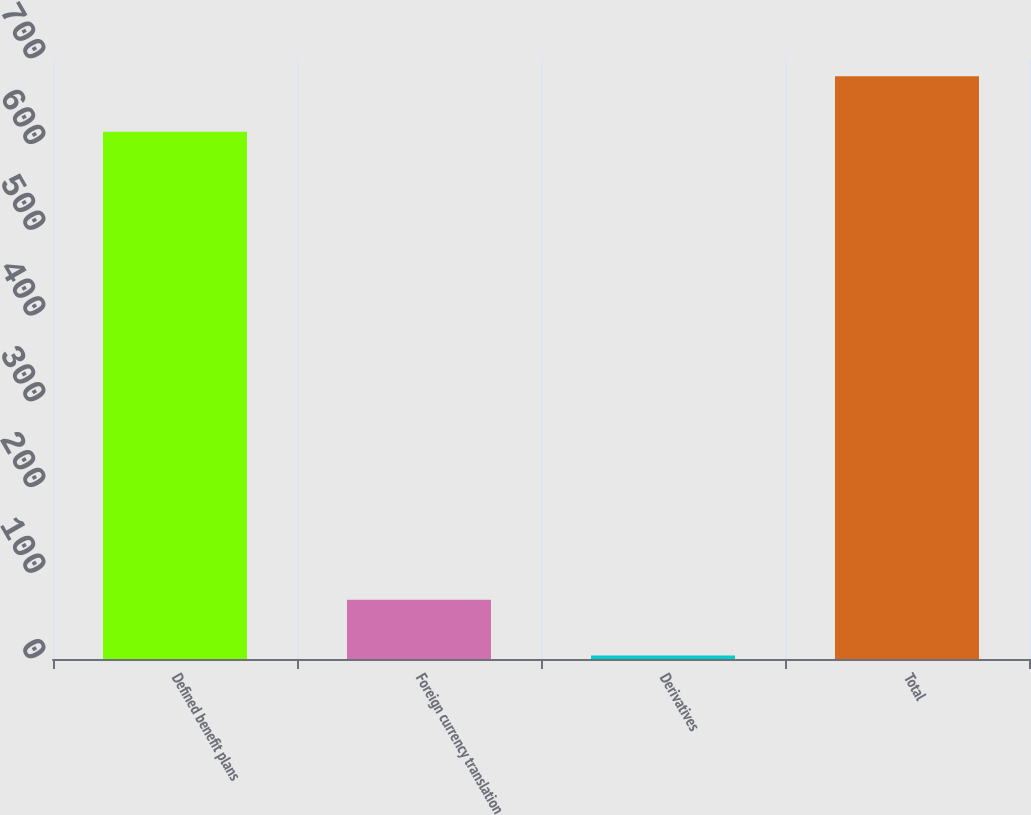<chart> <loc_0><loc_0><loc_500><loc_500><bar_chart><fcel>Defined benefit plans<fcel>Foreign currency translation<fcel>Derivatives<fcel>Total<nl><fcel>615<fcel>69<fcel>4<fcel>680<nl></chart> 